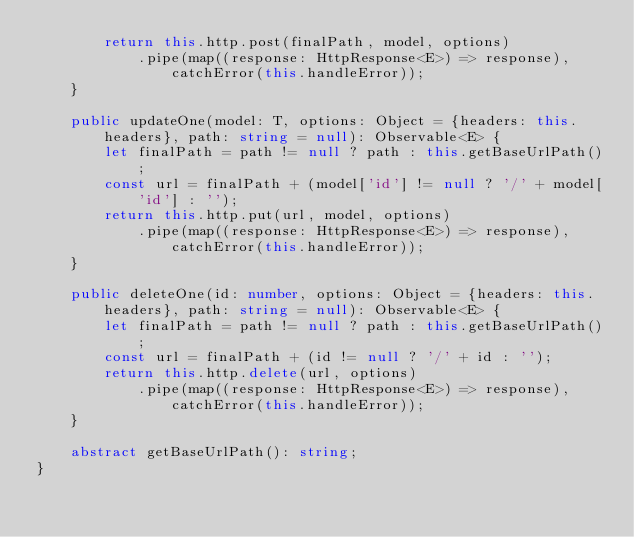Convert code to text. <code><loc_0><loc_0><loc_500><loc_500><_TypeScript_>        return this.http.post(finalPath, model, options)
            .pipe(map((response: HttpResponse<E>) => response), catchError(this.handleError));
    }

    public updateOne(model: T, options: Object = {headers: this.headers}, path: string = null): Observable<E> {
        let finalPath = path != null ? path : this.getBaseUrlPath();
        const url = finalPath + (model['id'] != null ? '/' + model['id'] : '');
        return this.http.put(url, model, options)
            .pipe(map((response: HttpResponse<E>) => response), catchError(this.handleError));
    }

    public deleteOne(id: number, options: Object = {headers: this.headers}, path: string = null): Observable<E> {
        let finalPath = path != null ? path : this.getBaseUrlPath();
        const url = finalPath + (id != null ? '/' + id : '');
        return this.http.delete(url, options)
            .pipe(map((response: HttpResponse<E>) => response), catchError(this.handleError));
    }

    abstract getBaseUrlPath(): string;
}
</code> 